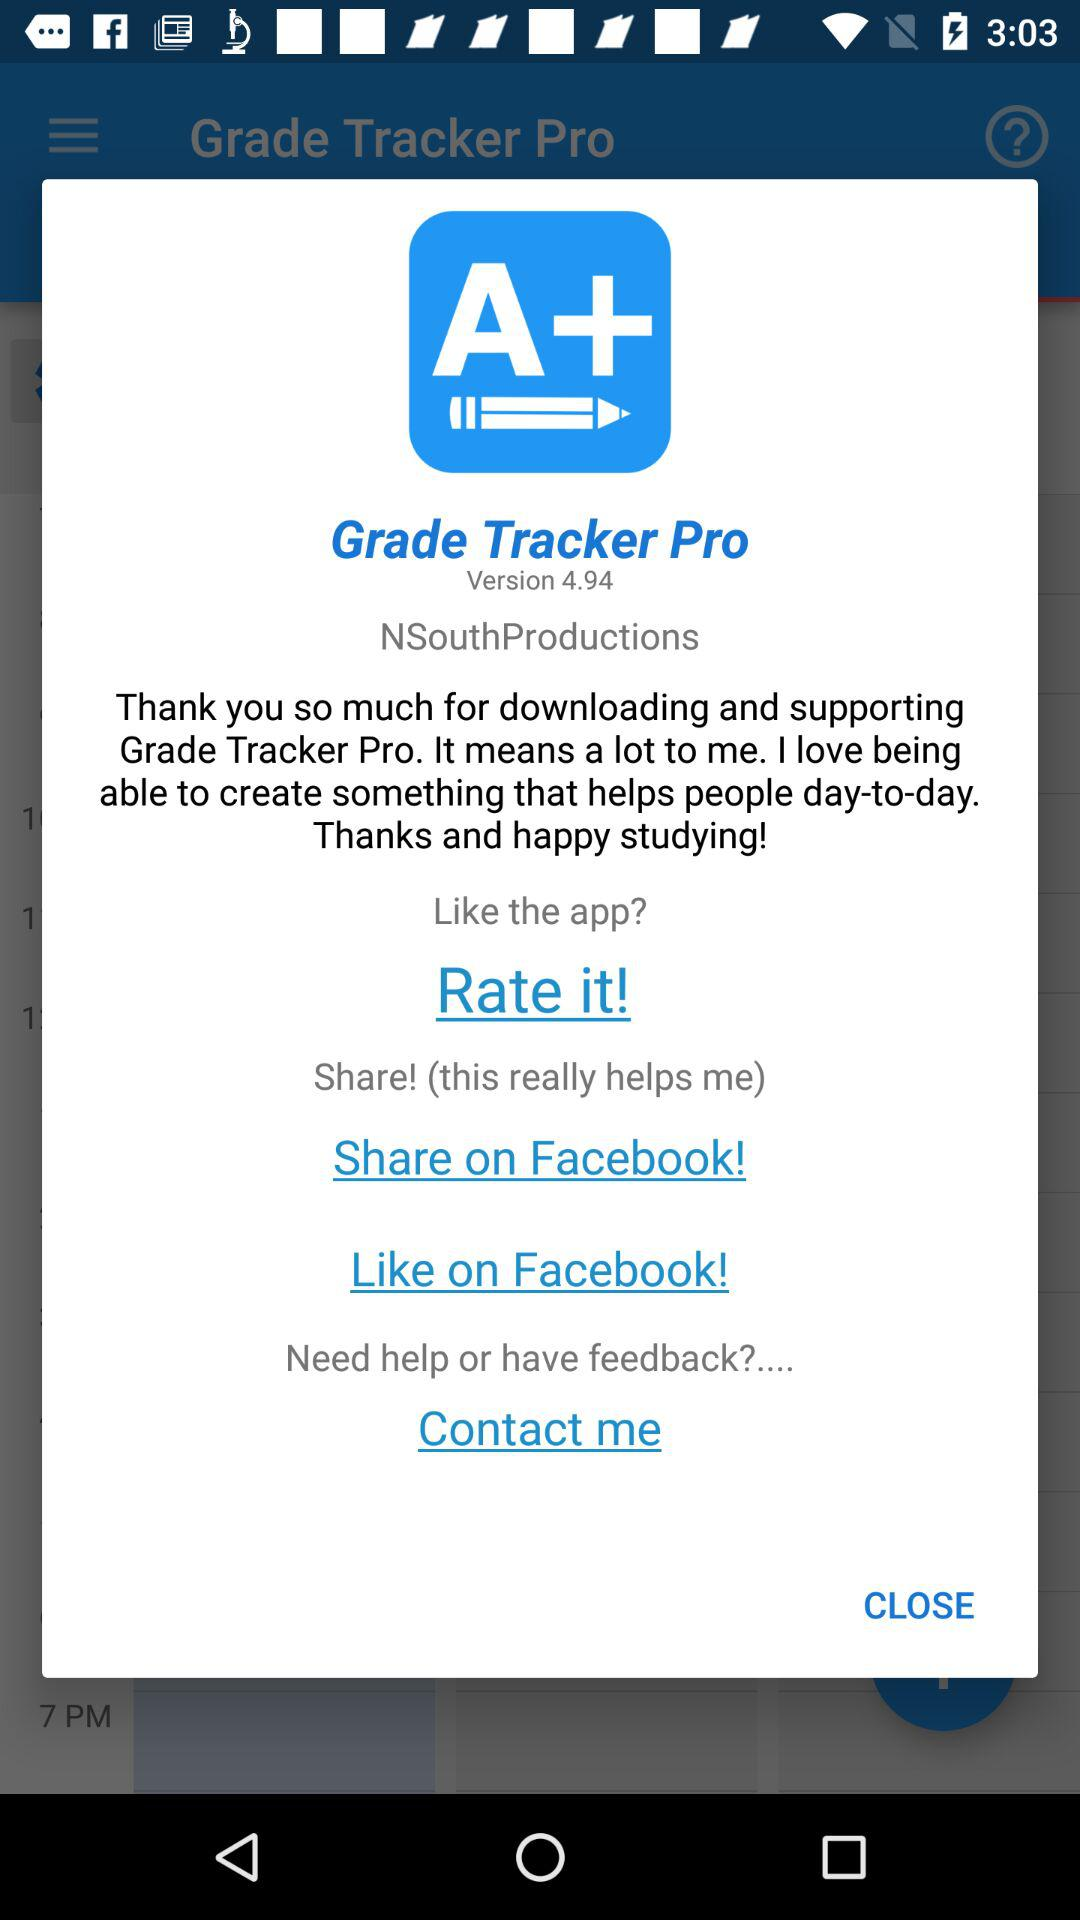What is the app name? The app name is "Grade Tracker Pro". 